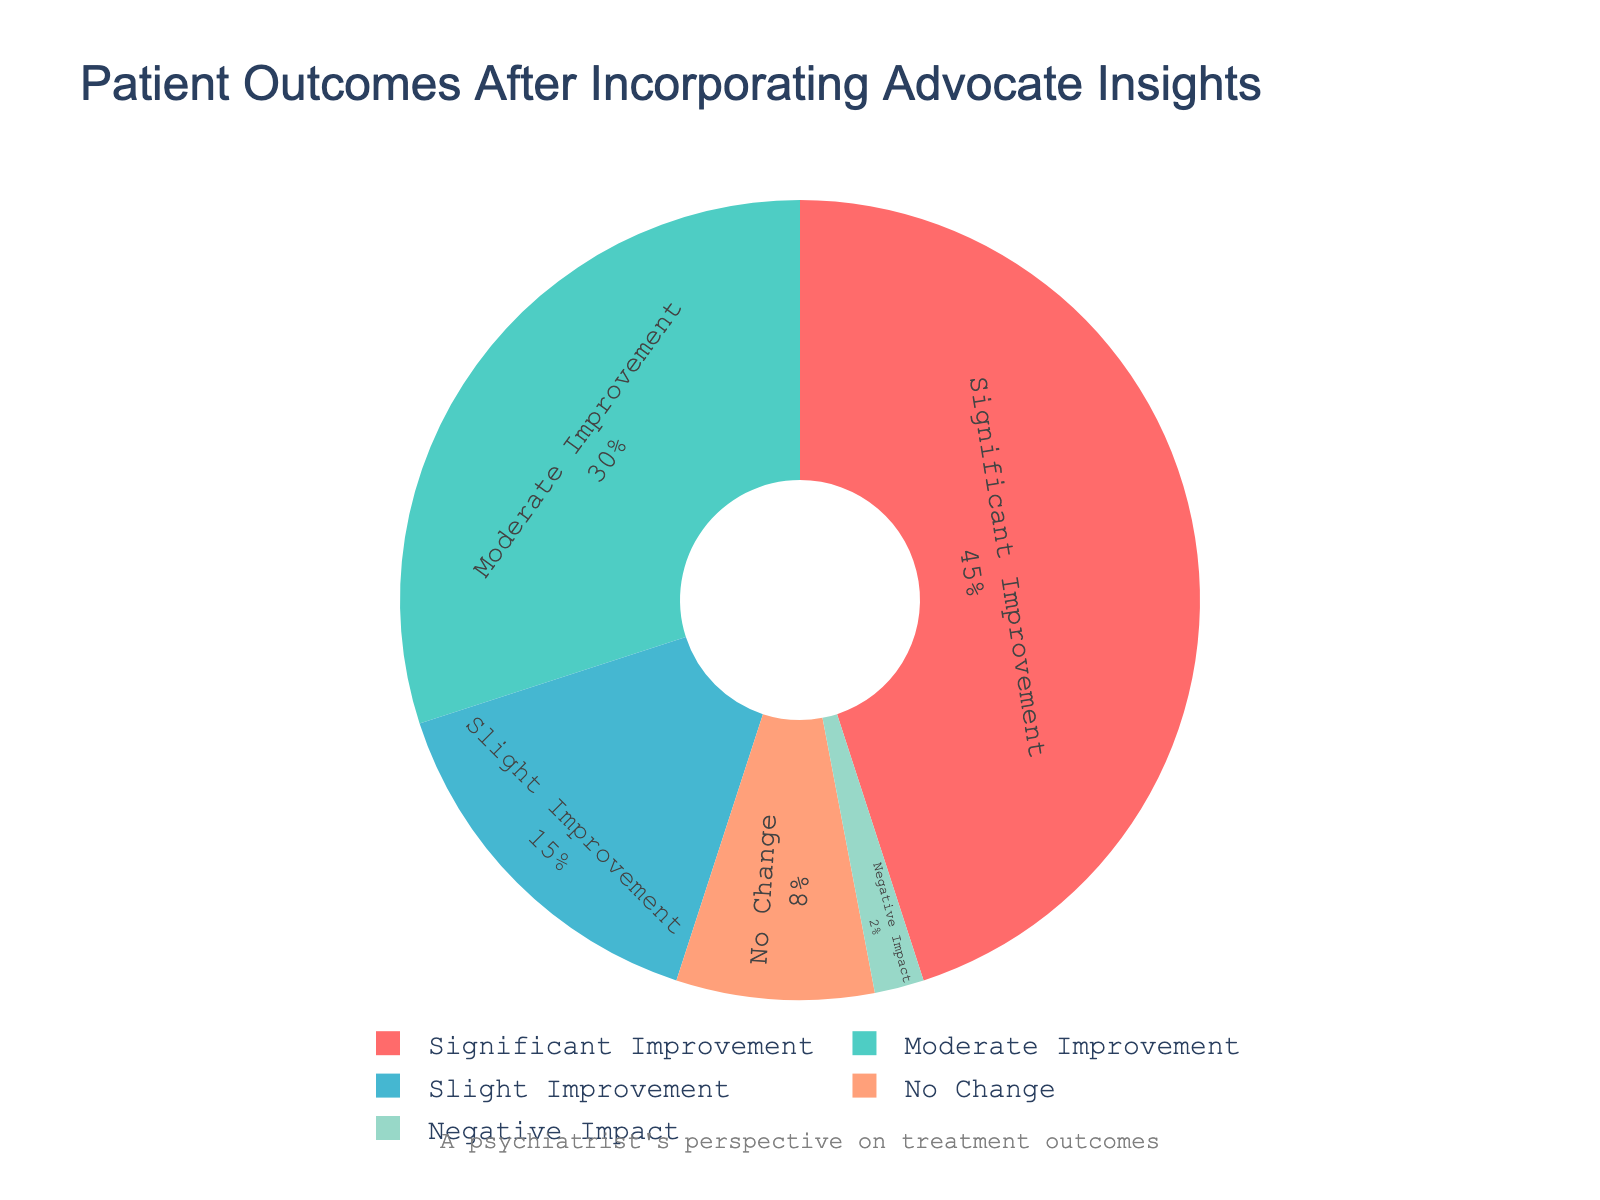Which category has the highest percentage of patient improvement? The segment with the largest portion represents "Significant Improvement" with a percentage of 45%.
Answer: Significant Improvement What is the combined percentage of patients who reported either significant or moderate improvement? Adding the percentages of "Significant Improvement" (45%) and "Moderate Improvement" (30%) gives a combined total of 75%.
Answer: 75% Is the percentage of patients with no change greater than those with a negative impact? Comparing the segments, "No Change" is 8% while "Negative Impact" is 2%, so 8% is greater than 2%.
Answer: Yes How much larger is the percentage of patients with significant improvement compared to those with slight improvement? Subtracting the percentage of "Slight Improvement" (15%) from "Significant Improvement" (45%) results in a difference of 30%.
Answer: 30% Sum up the percentages of patients reporting slight improvement, no change, and negative impact. Adding "Slight Improvement" (15%), "No Change" (8%), and "Negative Impact" (2%) results in a total of 25%.
Answer: 25% Which category has the smallest visual segment on the pie chart? The smallest segment represents "Negative Impact" with a percentage of 2%.
Answer: Negative Impact Are there more patients reporting moderate improvement or slight improvement? Comparing the segments, "Moderate Improvement" is 30% while "Slight Improvement" is 15%, so 30% is greater than 15%.
Answer: Moderate Improvement How does the percentage of patients with no change compare to the cumulative percentage of those experiencing negative impact and slight improvement? Adding "Negative Impact" (2%) and "Slight Improvement" (15%) equals 17%, which is greater than "No Change" at 8%.
Answer: Less Combining slight improvement and no change, how do they compare to significant improvement? Adding "Slight Improvement" (15%) and "No Change" (8%) equals 23%, which is less than "Significant Improvement" at 45%.
Answer: Less What is the difference between the total percentage of improvements and the total percentage of no improvement/negative impact? Summing "Significant Improvement" (45%), "Moderate Improvement" (30%), and "Slight Improvement" (15%) gives 90%. Summing "No Change" (8%) and "Negative Impact" (2%) gives 10%. The difference is 90% - 10% = 80%.
Answer: 80% 